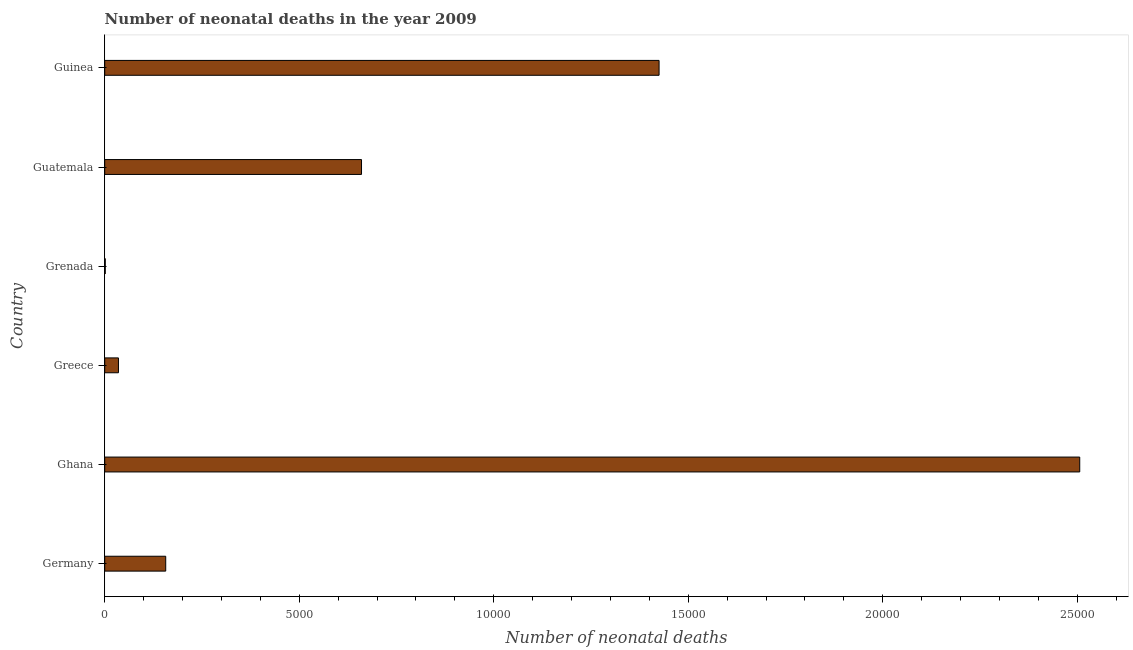Does the graph contain grids?
Provide a succinct answer. No. What is the title of the graph?
Offer a very short reply. Number of neonatal deaths in the year 2009. What is the label or title of the X-axis?
Ensure brevity in your answer.  Number of neonatal deaths. What is the label or title of the Y-axis?
Provide a short and direct response. Country. What is the number of neonatal deaths in Germany?
Offer a very short reply. 1568. Across all countries, what is the maximum number of neonatal deaths?
Keep it short and to the point. 2.51e+04. In which country was the number of neonatal deaths minimum?
Offer a terse response. Grenada. What is the sum of the number of neonatal deaths?
Give a very brief answer. 4.78e+04. What is the difference between the number of neonatal deaths in Ghana and Greece?
Your response must be concise. 2.47e+04. What is the average number of neonatal deaths per country?
Offer a terse response. 7974. What is the median number of neonatal deaths?
Offer a terse response. 4084.5. What is the ratio of the number of neonatal deaths in Ghana to that in Guinea?
Your response must be concise. 1.76. Is the number of neonatal deaths in Germany less than that in Greece?
Make the answer very short. No. Is the difference between the number of neonatal deaths in Germany and Guatemala greater than the difference between any two countries?
Keep it short and to the point. No. What is the difference between the highest and the second highest number of neonatal deaths?
Keep it short and to the point. 1.08e+04. What is the difference between the highest and the lowest number of neonatal deaths?
Your answer should be very brief. 2.50e+04. In how many countries, is the number of neonatal deaths greater than the average number of neonatal deaths taken over all countries?
Offer a terse response. 2. How many bars are there?
Your answer should be very brief. 6. Are all the bars in the graph horizontal?
Keep it short and to the point. Yes. What is the difference between two consecutive major ticks on the X-axis?
Your response must be concise. 5000. What is the Number of neonatal deaths in Germany?
Give a very brief answer. 1568. What is the Number of neonatal deaths in Ghana?
Provide a succinct answer. 2.51e+04. What is the Number of neonatal deaths of Greece?
Make the answer very short. 353. What is the Number of neonatal deaths of Grenada?
Provide a succinct answer. 14. What is the Number of neonatal deaths of Guatemala?
Provide a short and direct response. 6601. What is the Number of neonatal deaths of Guinea?
Your answer should be very brief. 1.42e+04. What is the difference between the Number of neonatal deaths in Germany and Ghana?
Keep it short and to the point. -2.35e+04. What is the difference between the Number of neonatal deaths in Germany and Greece?
Make the answer very short. 1215. What is the difference between the Number of neonatal deaths in Germany and Grenada?
Provide a succinct answer. 1554. What is the difference between the Number of neonatal deaths in Germany and Guatemala?
Your response must be concise. -5033. What is the difference between the Number of neonatal deaths in Germany and Guinea?
Provide a short and direct response. -1.27e+04. What is the difference between the Number of neonatal deaths in Ghana and Greece?
Make the answer very short. 2.47e+04. What is the difference between the Number of neonatal deaths in Ghana and Grenada?
Provide a short and direct response. 2.50e+04. What is the difference between the Number of neonatal deaths in Ghana and Guatemala?
Your response must be concise. 1.85e+04. What is the difference between the Number of neonatal deaths in Ghana and Guinea?
Your response must be concise. 1.08e+04. What is the difference between the Number of neonatal deaths in Greece and Grenada?
Provide a succinct answer. 339. What is the difference between the Number of neonatal deaths in Greece and Guatemala?
Your answer should be compact. -6248. What is the difference between the Number of neonatal deaths in Greece and Guinea?
Your response must be concise. -1.39e+04. What is the difference between the Number of neonatal deaths in Grenada and Guatemala?
Provide a short and direct response. -6587. What is the difference between the Number of neonatal deaths in Grenada and Guinea?
Ensure brevity in your answer.  -1.42e+04. What is the difference between the Number of neonatal deaths in Guatemala and Guinea?
Keep it short and to the point. -7649. What is the ratio of the Number of neonatal deaths in Germany to that in Ghana?
Ensure brevity in your answer.  0.06. What is the ratio of the Number of neonatal deaths in Germany to that in Greece?
Provide a short and direct response. 4.44. What is the ratio of the Number of neonatal deaths in Germany to that in Grenada?
Your answer should be very brief. 112. What is the ratio of the Number of neonatal deaths in Germany to that in Guatemala?
Keep it short and to the point. 0.24. What is the ratio of the Number of neonatal deaths in Germany to that in Guinea?
Make the answer very short. 0.11. What is the ratio of the Number of neonatal deaths in Ghana to that in Grenada?
Provide a short and direct response. 1790.21. What is the ratio of the Number of neonatal deaths in Ghana to that in Guatemala?
Your answer should be compact. 3.8. What is the ratio of the Number of neonatal deaths in Ghana to that in Guinea?
Keep it short and to the point. 1.76. What is the ratio of the Number of neonatal deaths in Greece to that in Grenada?
Give a very brief answer. 25.21. What is the ratio of the Number of neonatal deaths in Greece to that in Guatemala?
Offer a terse response. 0.05. What is the ratio of the Number of neonatal deaths in Greece to that in Guinea?
Ensure brevity in your answer.  0.03. What is the ratio of the Number of neonatal deaths in Grenada to that in Guatemala?
Provide a short and direct response. 0. What is the ratio of the Number of neonatal deaths in Guatemala to that in Guinea?
Offer a very short reply. 0.46. 